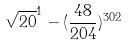<formula> <loc_0><loc_0><loc_500><loc_500>\sqrt { 2 0 } ^ { 1 } - ( \frac { 4 8 } { 2 0 4 } ) ^ { 3 0 2 }</formula> 